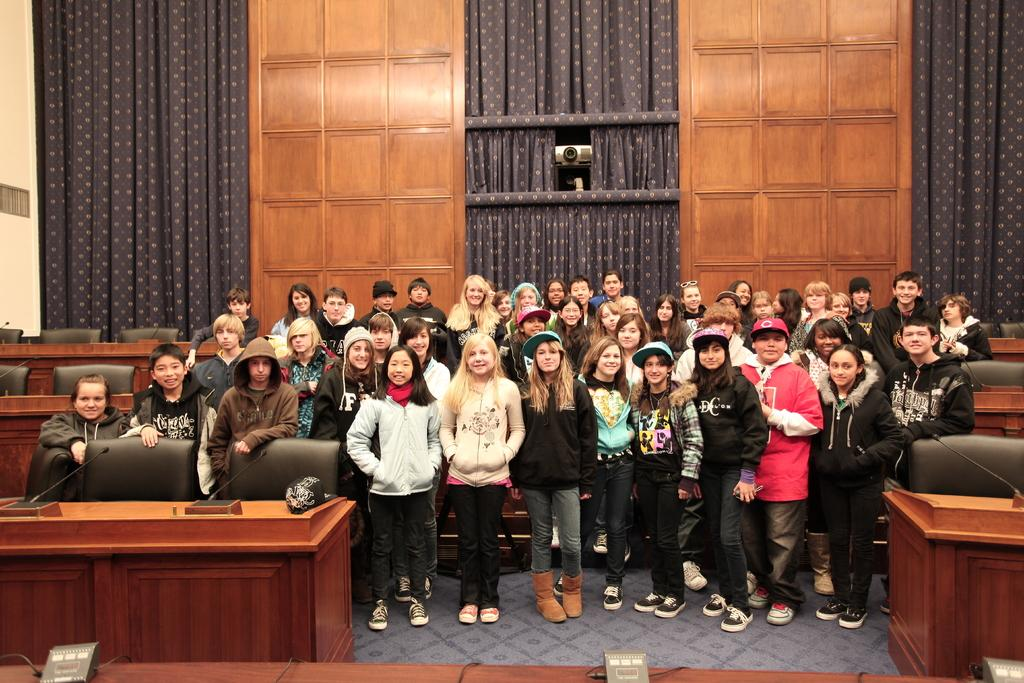How many people are in the image? There is a group of people in the image. What type of surface is visible in the image? The image shows a floor. What type of furniture is present in the image? There are chairs and tables in the image. What can be seen in the background of the image? There is a wall, curtains, and a camera visible in the background of the image. What objects are on the table in the image? Microphones are on the table in the image. Can you hear the harmony of the lake in the image? There is no lake present in the image, so it is not possible to hear any harmony from it. 